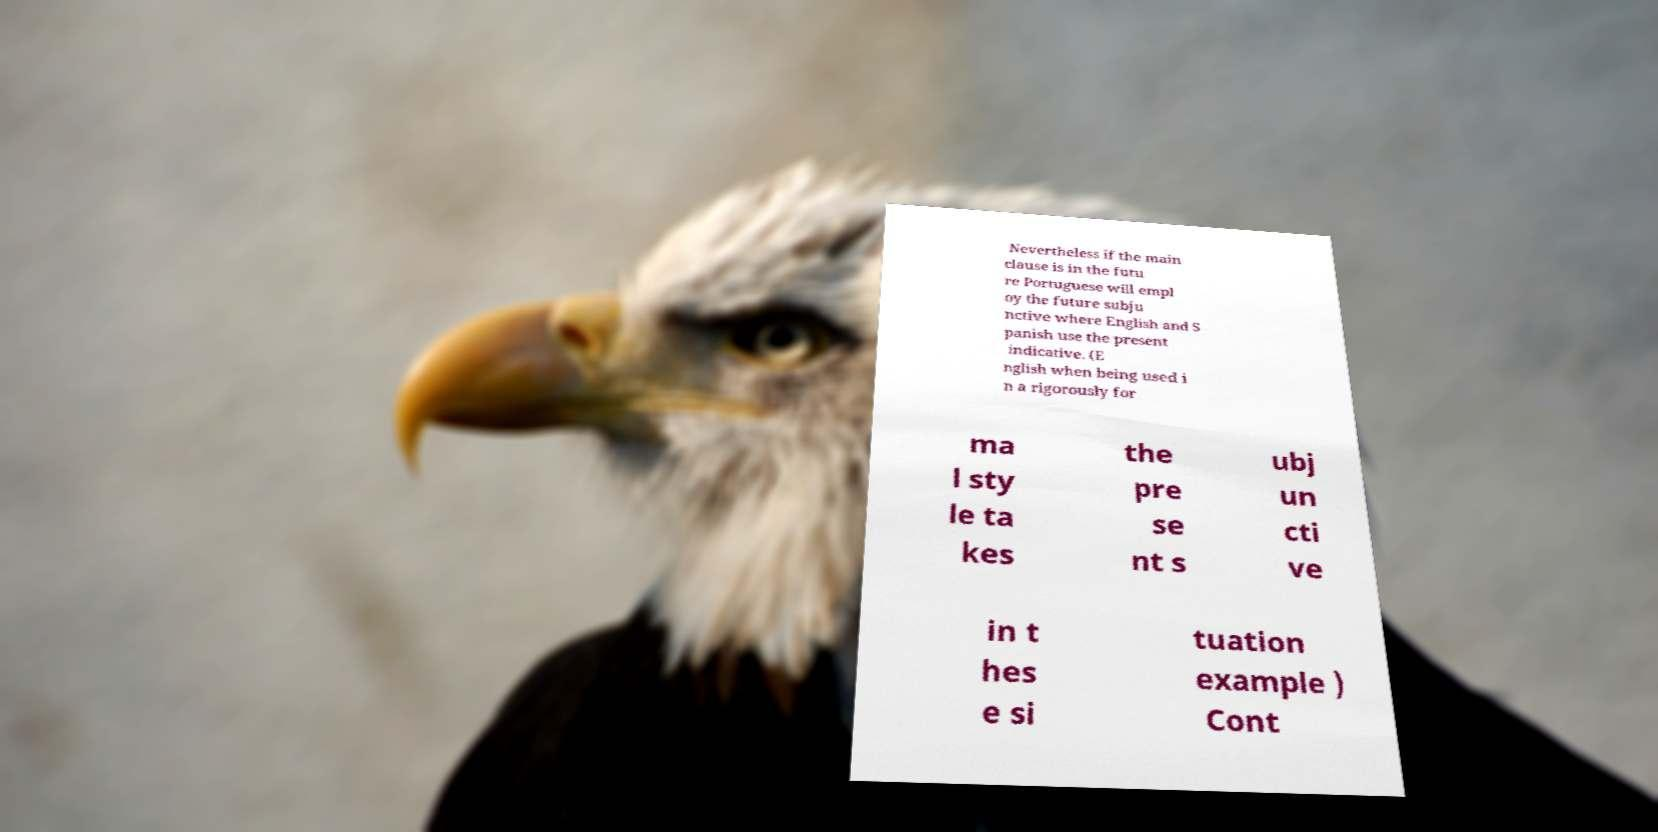What messages or text are displayed in this image? I need them in a readable, typed format. Nevertheless if the main clause is in the futu re Portuguese will empl oy the future subju nctive where English and S panish use the present indicative. (E nglish when being used i n a rigorously for ma l sty le ta kes the pre se nt s ubj un cti ve in t hes e si tuation example ) Cont 